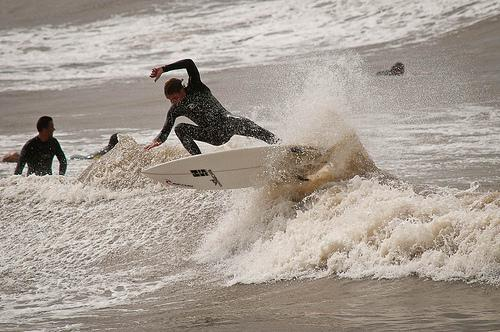Question: who is in the center?
Choices:
A. A man.
B. A child.
C. A boy.
D. A girl.
Answer with the letter. Answer: A Question: what is he doing?
Choices:
A. Surfing.
B. Running.
C. Jogging.
D. Sleeping.
Answer with the letter. Answer: A Question: what is he wearing?
Choices:
A. A suit.
B. A wetsuit.
C. A shirt.
D. A pair of pants.
Answer with the letter. Answer: B Question: what is in the background?
Choices:
A. A mountain.
B. A ravine.
C. A cliff.
D. Ocean surf.
Answer with the letter. Answer: D Question: what is in the foreground?
Choices:
A. The shore line.
B. The ocean.
C. Boats.
D. People on the beach.
Answer with the letter. Answer: A 